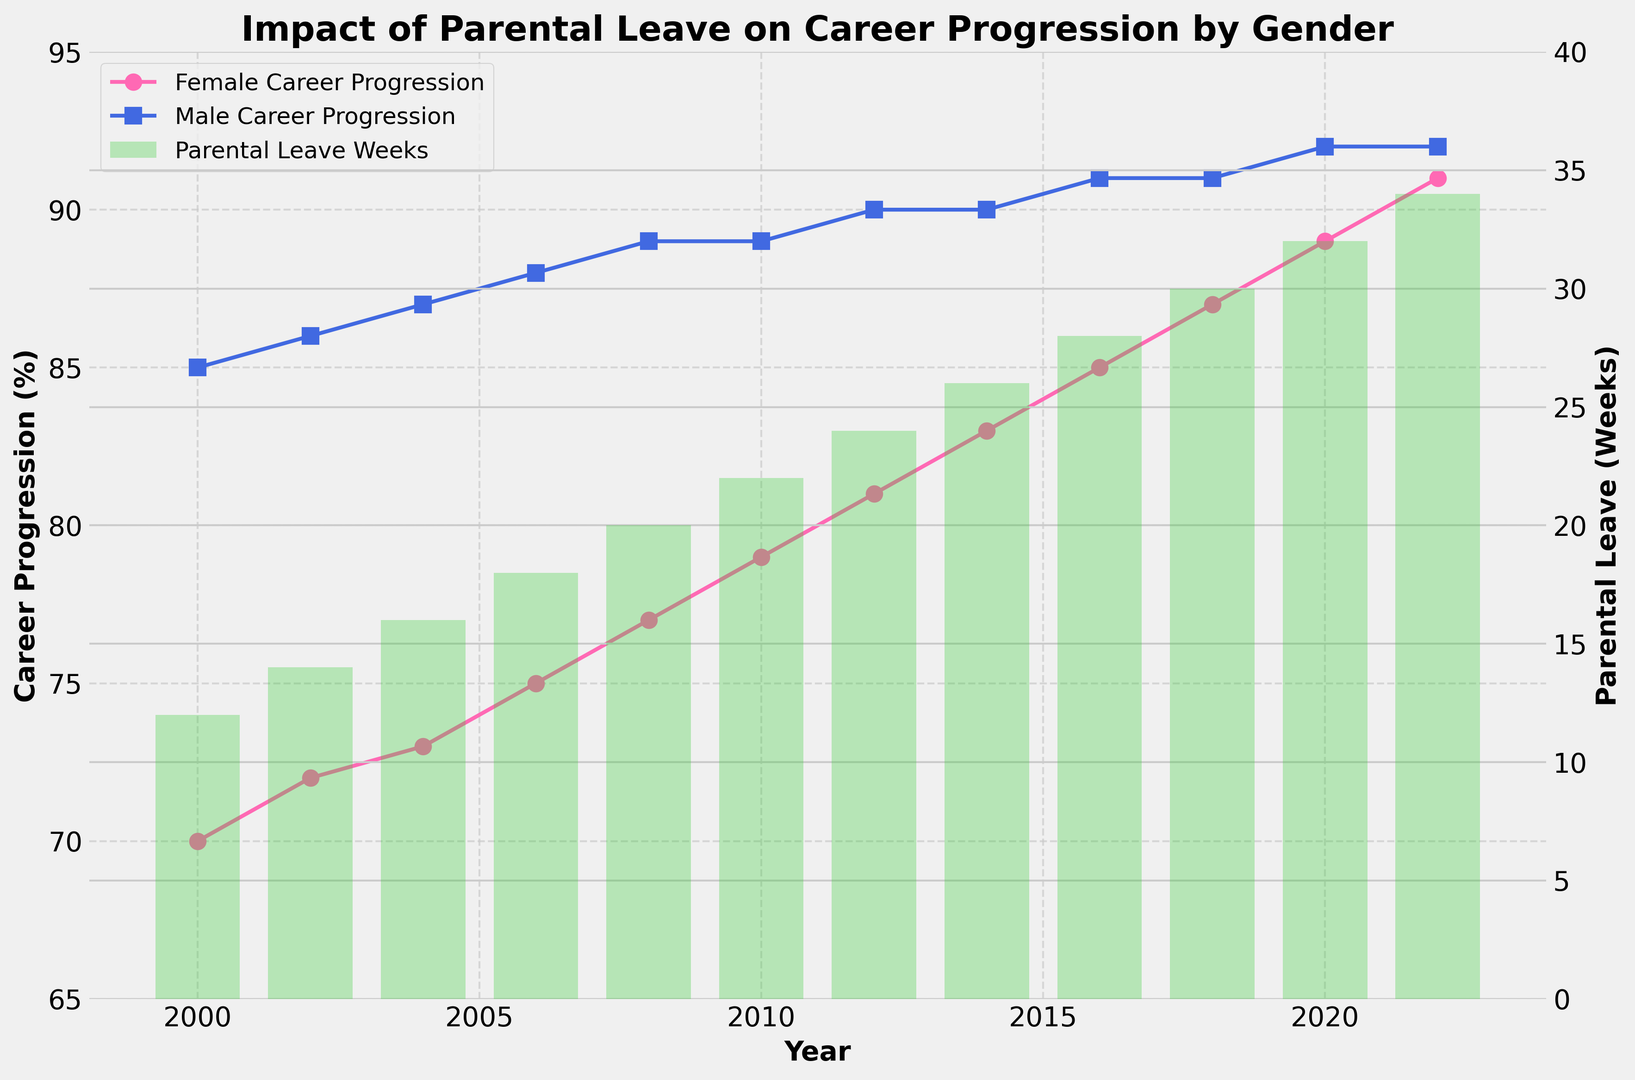what is the difference in career progression between males and females in 2020? In 2020, the male career progression is 92% and the female career progression is 89%. The difference is 92 - 89 = 3%.
Answer: 3% which year shows the highest increase in female career progression compared to the previous year? From the plot, the highest increases in female career progression occur between consecutive years. By comparing the differences for each pair of consecutive years: 2000-2002 (2%), 2002-2004 (1%), 2004-2006 (2%), 2006-2008 (2%), 2008-2010 (2%), 2010-2012 (2%), 2012-2014 (2%), 2014-2016 (2%), 2016-2018 (2%), 2018-2020 (2%), 2020-2022 (2%), the year with the highest increase is from 2000 to 2002 and from 2006 to 2008.
Answer: 2000-2002, 2006-2008 by how many weeks did parental leave increase from 2008 to 2022? From the plot, in 2008, parental leave was 20 weeks, and in 2022, it was 34 weeks. The increase is 34 - 20 = 14 weeks.
Answer: 14 weeks which year did both genders have the same career progression percentage? Interpretation of the plot shows that both genders had the same career progression percentage in 2022, with both at 92%.
Answer: 2022 which gender had a higher career progression percentage in 2004, and by how much? In 2004, the female career progression percentage was 73%, and the male career progression percentage was 87%. The male career progression was higher by 87 - 73 = 14%.
Answer: male, 14% how does the trend in parental leave correlate with female career progression from 2000 to 2022? Observing the plot, as the number of parental leave weeks increased from 12 weeks in 2000 to 34 weeks in 2022, female career progression also steadily increased from 70% to 91%. This indicates a positive correlation between the two.
Answer: positively correlated compare the average career progression percentage of females and males over the entire period. To calculate the average:
Females: (70 + 72 + 73 + 75 + 77 + 79 + 81 + 83 + 85 + 87 + 89 + 91) / 12 = 79.08%
Males: (85 + 86 + 87 + 88 + 89 + 89 + 90 + 90 + 91 + 91 + 92 + 92) / 12 = 89.08%
Answer: Females: 79.08%, Males: 89.08% in which years did the amount of parental leave increase by exactly 2 weeks compared to the previous year? By examining the bars in the plot:
From 2000 to 2002: Increase by 2 weeks
From 2002 to 2004: Increase by 2 weeks
From 2006 to 2008: Increase by 2 weeks
From 2008 to 2010: Increase by 2 weeks
From 2010 to 2012: Increase by 2 weeks
From 2012 to 2014: Increase by 2 weeks
From 2014 to 2016: Increase by 2 weeks
From 2016 to 2018: Increase by 2 weeks
From 2018 to 2020: Increase by 2 weeks
From 2020 to 2022: Increase by 2 weeks
Answer: 2000-2002, 2002-2004, 2006-2008, 2008-2010, 2010-2012, 2012-2014, 2014-2016, 2016-2018, 2018-2020, 2020-2022 